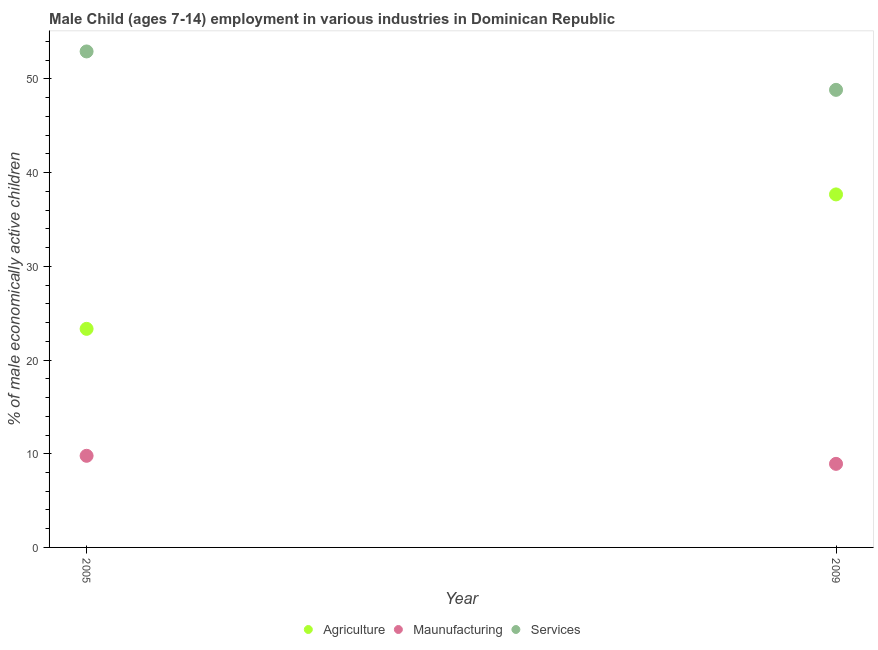Is the number of dotlines equal to the number of legend labels?
Your answer should be very brief. Yes. What is the percentage of economically active children in agriculture in 2009?
Keep it short and to the point. 37.68. Across all years, what is the maximum percentage of economically active children in manufacturing?
Ensure brevity in your answer.  9.78. Across all years, what is the minimum percentage of economically active children in manufacturing?
Offer a very short reply. 8.92. In which year was the percentage of economically active children in services maximum?
Give a very brief answer. 2005. What is the total percentage of economically active children in manufacturing in the graph?
Your answer should be very brief. 18.7. What is the difference between the percentage of economically active children in manufacturing in 2005 and that in 2009?
Offer a very short reply. 0.86. What is the difference between the percentage of economically active children in services in 2005 and the percentage of economically active children in manufacturing in 2009?
Offer a terse response. 44.02. What is the average percentage of economically active children in services per year?
Provide a short and direct response. 50.89. In the year 2009, what is the difference between the percentage of economically active children in services and percentage of economically active children in agriculture?
Keep it short and to the point. 11.16. What is the ratio of the percentage of economically active children in manufacturing in 2005 to that in 2009?
Ensure brevity in your answer.  1.1. Is it the case that in every year, the sum of the percentage of economically active children in agriculture and percentage of economically active children in manufacturing is greater than the percentage of economically active children in services?
Offer a very short reply. No. Does the percentage of economically active children in agriculture monotonically increase over the years?
Your answer should be compact. Yes. Is the percentage of economically active children in agriculture strictly greater than the percentage of economically active children in services over the years?
Give a very brief answer. No. Is the percentage of economically active children in manufacturing strictly less than the percentage of economically active children in services over the years?
Provide a short and direct response. Yes. How many dotlines are there?
Offer a very short reply. 3. What is the difference between two consecutive major ticks on the Y-axis?
Provide a succinct answer. 10. Does the graph contain any zero values?
Your response must be concise. No. Where does the legend appear in the graph?
Provide a short and direct response. Bottom center. How are the legend labels stacked?
Your answer should be compact. Horizontal. What is the title of the graph?
Your response must be concise. Male Child (ages 7-14) employment in various industries in Dominican Republic. What is the label or title of the X-axis?
Make the answer very short. Year. What is the label or title of the Y-axis?
Your answer should be compact. % of male economically active children. What is the % of male economically active children of Agriculture in 2005?
Offer a very short reply. 23.33. What is the % of male economically active children of Maunufacturing in 2005?
Ensure brevity in your answer.  9.78. What is the % of male economically active children of Services in 2005?
Your answer should be compact. 52.94. What is the % of male economically active children of Agriculture in 2009?
Offer a very short reply. 37.68. What is the % of male economically active children in Maunufacturing in 2009?
Give a very brief answer. 8.92. What is the % of male economically active children in Services in 2009?
Offer a terse response. 48.84. Across all years, what is the maximum % of male economically active children of Agriculture?
Offer a terse response. 37.68. Across all years, what is the maximum % of male economically active children of Maunufacturing?
Provide a short and direct response. 9.78. Across all years, what is the maximum % of male economically active children of Services?
Ensure brevity in your answer.  52.94. Across all years, what is the minimum % of male economically active children in Agriculture?
Your answer should be very brief. 23.33. Across all years, what is the minimum % of male economically active children in Maunufacturing?
Make the answer very short. 8.92. Across all years, what is the minimum % of male economically active children in Services?
Ensure brevity in your answer.  48.84. What is the total % of male economically active children in Agriculture in the graph?
Your answer should be compact. 61.01. What is the total % of male economically active children of Maunufacturing in the graph?
Your answer should be compact. 18.7. What is the total % of male economically active children in Services in the graph?
Provide a succinct answer. 101.78. What is the difference between the % of male economically active children of Agriculture in 2005 and that in 2009?
Your response must be concise. -14.35. What is the difference between the % of male economically active children in Maunufacturing in 2005 and that in 2009?
Your answer should be very brief. 0.86. What is the difference between the % of male economically active children in Services in 2005 and that in 2009?
Your answer should be compact. 4.1. What is the difference between the % of male economically active children in Agriculture in 2005 and the % of male economically active children in Maunufacturing in 2009?
Your answer should be compact. 14.41. What is the difference between the % of male economically active children in Agriculture in 2005 and the % of male economically active children in Services in 2009?
Keep it short and to the point. -25.51. What is the difference between the % of male economically active children in Maunufacturing in 2005 and the % of male economically active children in Services in 2009?
Offer a terse response. -39.06. What is the average % of male economically active children in Agriculture per year?
Ensure brevity in your answer.  30.5. What is the average % of male economically active children in Maunufacturing per year?
Give a very brief answer. 9.35. What is the average % of male economically active children of Services per year?
Provide a short and direct response. 50.89. In the year 2005, what is the difference between the % of male economically active children in Agriculture and % of male economically active children in Maunufacturing?
Offer a terse response. 13.55. In the year 2005, what is the difference between the % of male economically active children of Agriculture and % of male economically active children of Services?
Give a very brief answer. -29.61. In the year 2005, what is the difference between the % of male economically active children in Maunufacturing and % of male economically active children in Services?
Offer a very short reply. -43.16. In the year 2009, what is the difference between the % of male economically active children in Agriculture and % of male economically active children in Maunufacturing?
Provide a succinct answer. 28.76. In the year 2009, what is the difference between the % of male economically active children of Agriculture and % of male economically active children of Services?
Your response must be concise. -11.16. In the year 2009, what is the difference between the % of male economically active children in Maunufacturing and % of male economically active children in Services?
Your response must be concise. -39.92. What is the ratio of the % of male economically active children of Agriculture in 2005 to that in 2009?
Offer a very short reply. 0.62. What is the ratio of the % of male economically active children in Maunufacturing in 2005 to that in 2009?
Give a very brief answer. 1.1. What is the ratio of the % of male economically active children of Services in 2005 to that in 2009?
Offer a very short reply. 1.08. What is the difference between the highest and the second highest % of male economically active children in Agriculture?
Give a very brief answer. 14.35. What is the difference between the highest and the second highest % of male economically active children of Maunufacturing?
Provide a succinct answer. 0.86. What is the difference between the highest and the second highest % of male economically active children in Services?
Provide a short and direct response. 4.1. What is the difference between the highest and the lowest % of male economically active children of Agriculture?
Provide a short and direct response. 14.35. What is the difference between the highest and the lowest % of male economically active children in Maunufacturing?
Your answer should be compact. 0.86. 